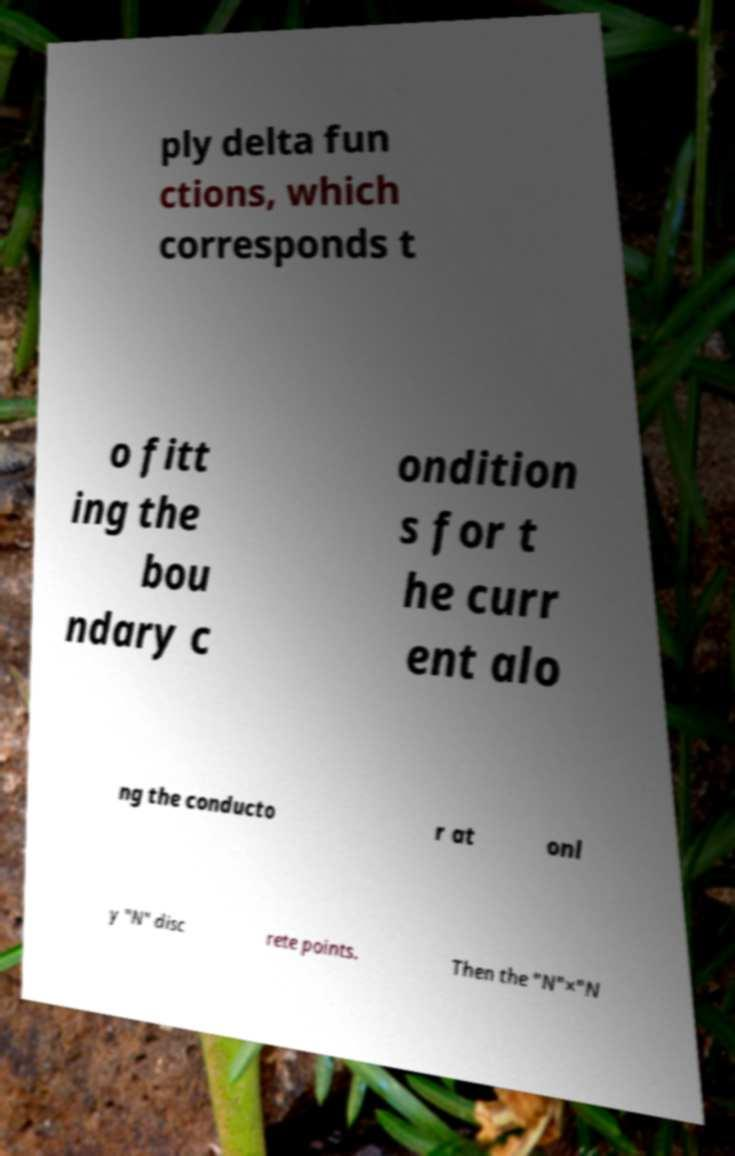What messages or text are displayed in this image? I need them in a readable, typed format. ply delta fun ctions, which corresponds t o fitt ing the bou ndary c ondition s for t he curr ent alo ng the conducto r at onl y "N" disc rete points. Then the "N"×"N 